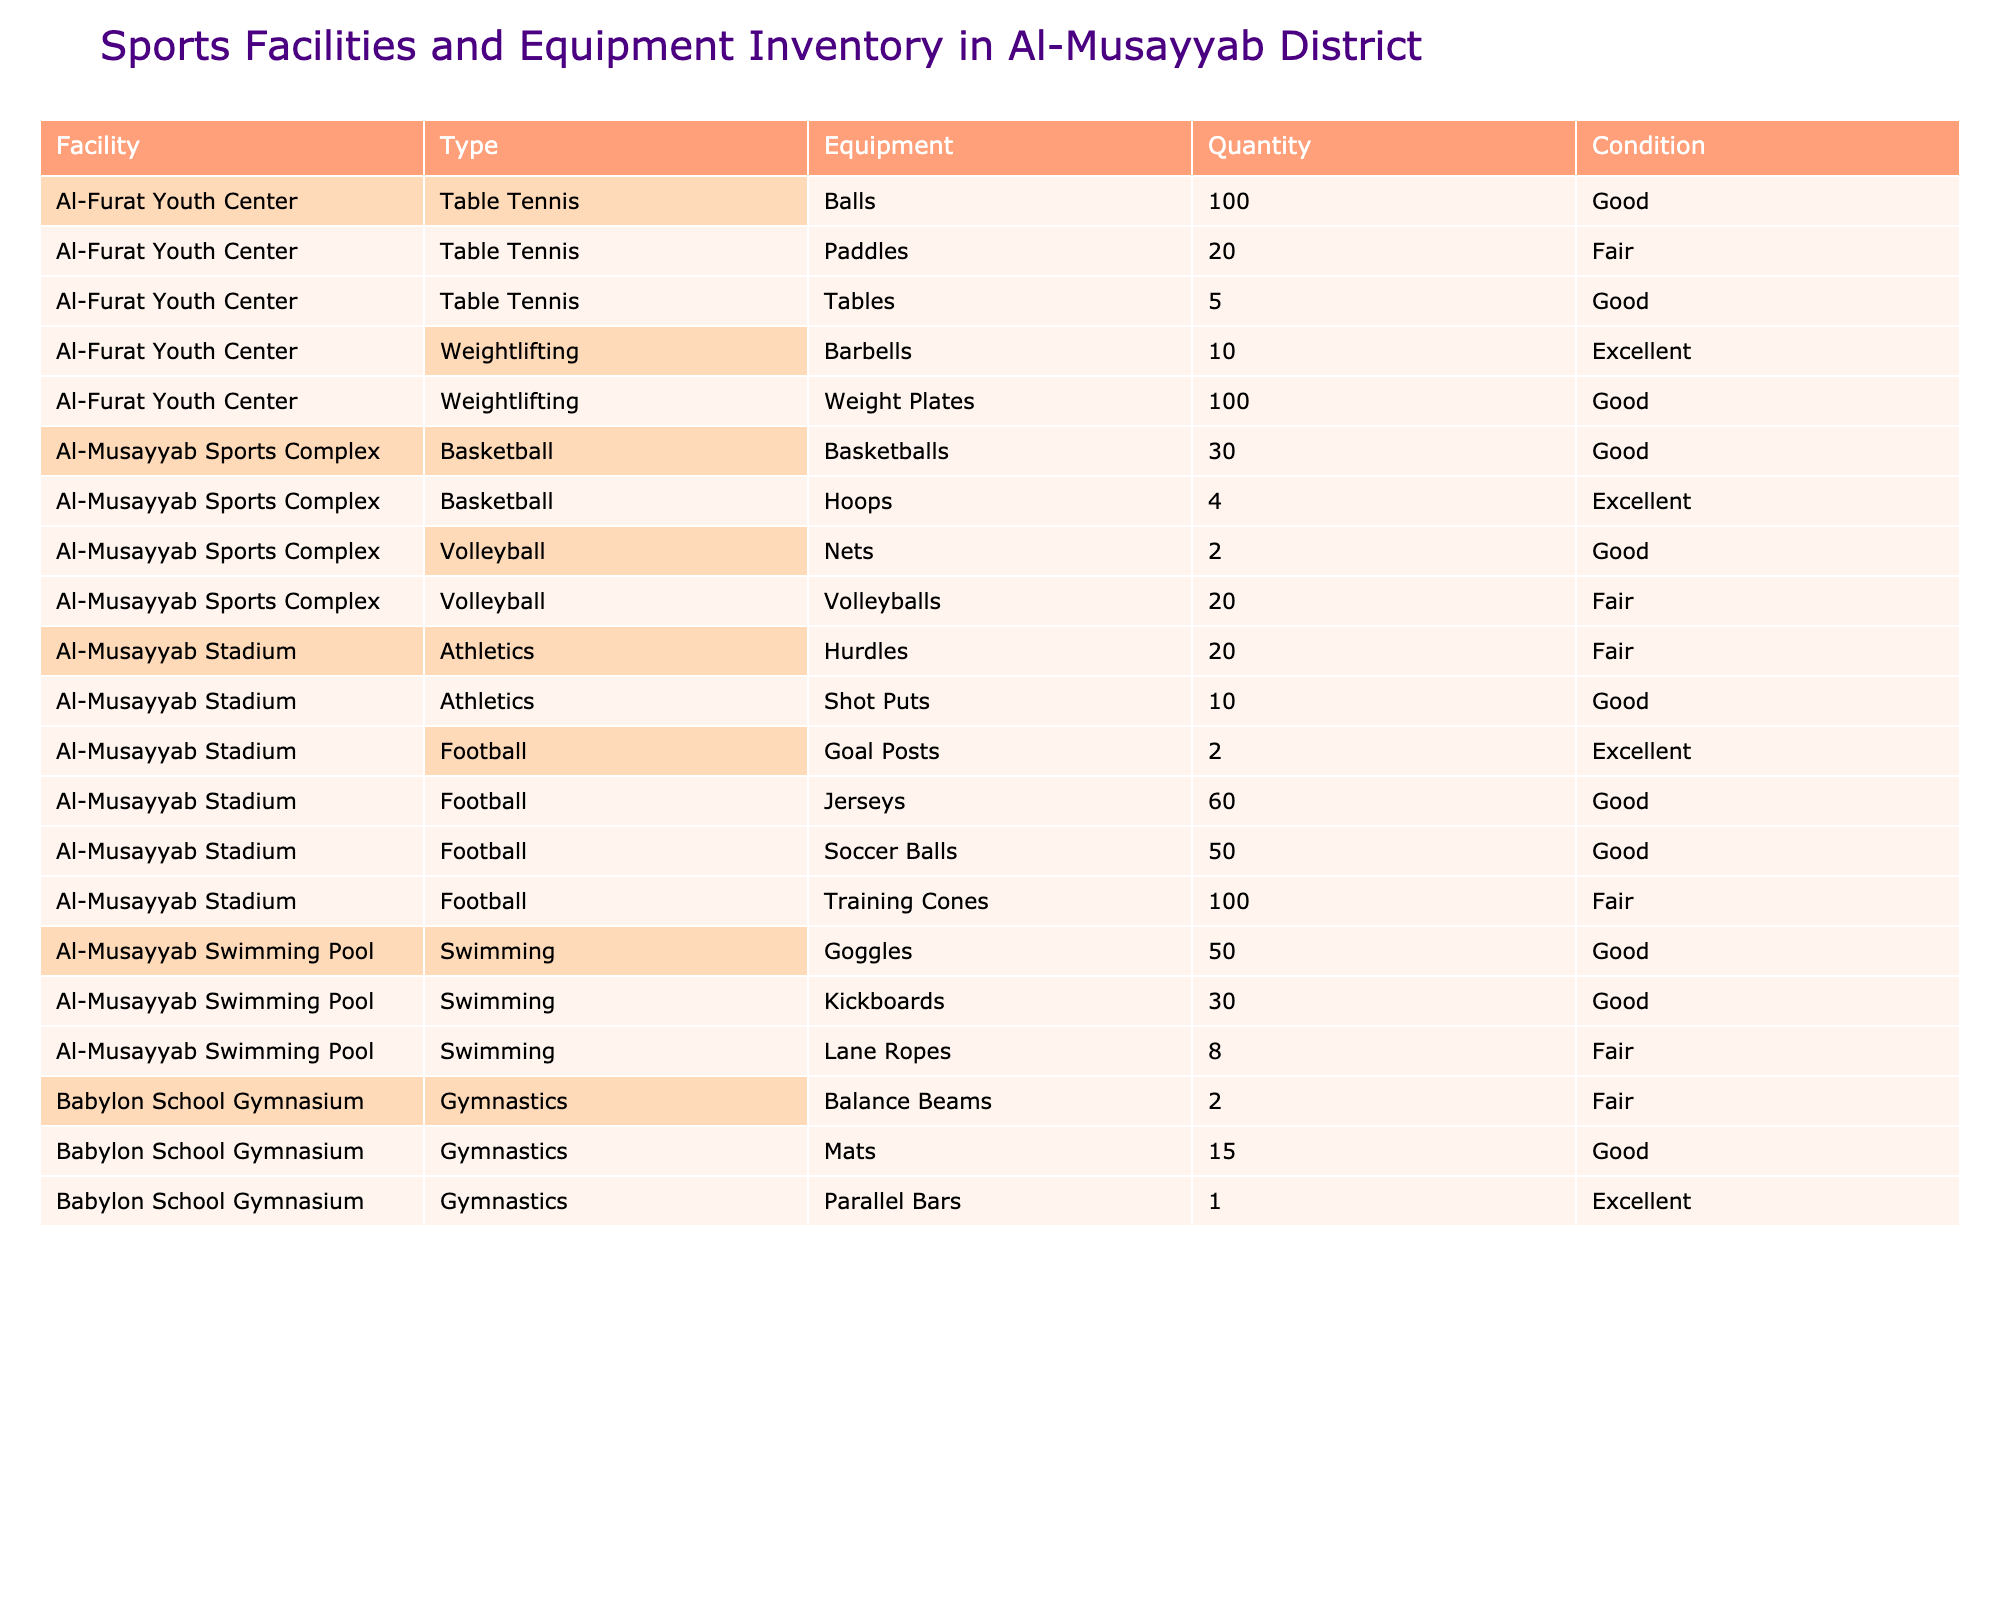What is the total quantity of soccer balls available in Al-Musayyab Stadium? There are 50 soccer balls listed under Al-Musayyab Stadium in the Football category.
Answer: 50 How many types of sports equipment are listed for the Al-Musayyab Sports Complex? The Al-Musayyab Sports Complex has 4 types of sports equipment listed: Basketball (2 types) and Volleyball (2 types).
Answer: 4 Are there any gymnastic equipment available in Al-Musayyab District facilities? Yes, the Babylon School Gymnasium has gymnastics equipment: Balance Beams, Mats, and Parallel Bars.
Answer: Yes Which facility has the highest quantity of equipment? The Al-Musayyab Stadium has the highest total quantity when summing individual equipment: 50 (Soccer Balls) + 2 (Goal Posts) + 100 (Training Cones) + 60 (Jerseys) + 20 (Hurdles) + 10 (Shot Puts) = 242 total.
Answer: Al-Musayyab Stadium What is the condition of the training cones at Al-Musayyab Stadium? The table indicates that the training cones at Al-Musayyab Stadium are in 'Fair' condition.
Answer: Fair How many more jerseys than goal posts are available at Al-Musayyab Stadium? The quantity of jerseys is 60 and the quantity of goal posts is 2, thus 60 - 2 = 58 more jerseys than goal posts.
Answer: 58 Which facility has the least amount of equipment overall? The Babylon School Gymnasium has a total of 18 items (2 Balance Beams + 15 Mats + 1 Parallel Bar).
Answer: Babylon School Gymnasium How many swimming goggles are available in the Al-Musayyab Swimming Pool? The inventory indicates there are 50 swimming goggles available at the Al-Musayyab Swimming Pool.
Answer: 50 Is any equipment in the 'Excellent' condition at Al-Furat Youth Center? Yes, the Weightlifting area has 10 Barbells listed in 'Excellent' condition.
Answer: Yes What is the average quantity of table tennis balls across all facilities? The total quantity of table tennis balls is 100 from Al-Furat Youth Center, and since there is only one listing, the average is 100/1 = 100.
Answer: 100 